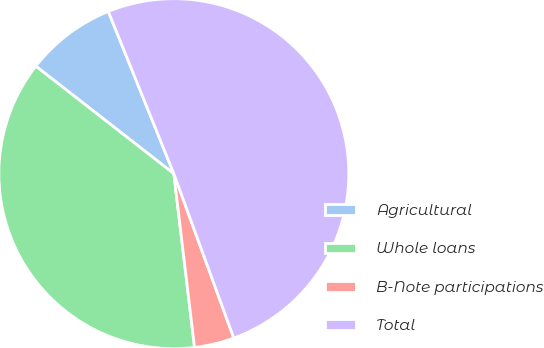<chart> <loc_0><loc_0><loc_500><loc_500><pie_chart><fcel>Agricultural<fcel>Whole loans<fcel>B-Note participations<fcel>Total<nl><fcel>8.36%<fcel>37.42%<fcel>3.68%<fcel>50.54%<nl></chart> 